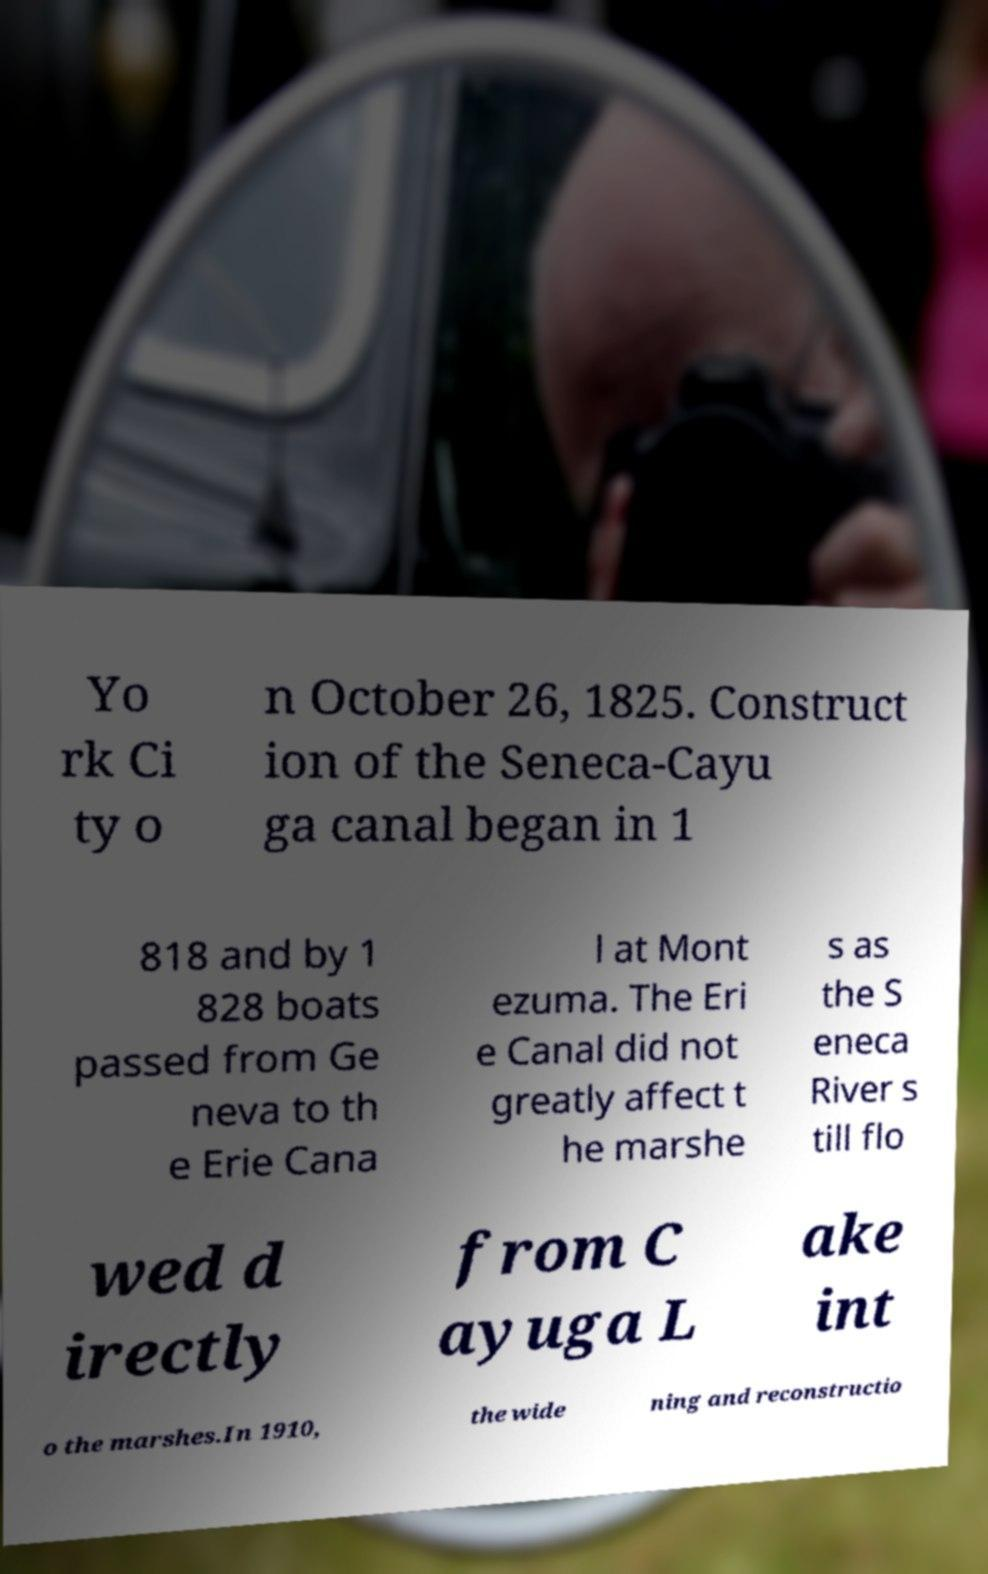Could you extract and type out the text from this image? Yo rk Ci ty o n October 26, 1825. Construct ion of the Seneca-Cayu ga canal began in 1 818 and by 1 828 boats passed from Ge neva to th e Erie Cana l at Mont ezuma. The Eri e Canal did not greatly affect t he marshe s as the S eneca River s till flo wed d irectly from C ayuga L ake int o the marshes.In 1910, the wide ning and reconstructio 